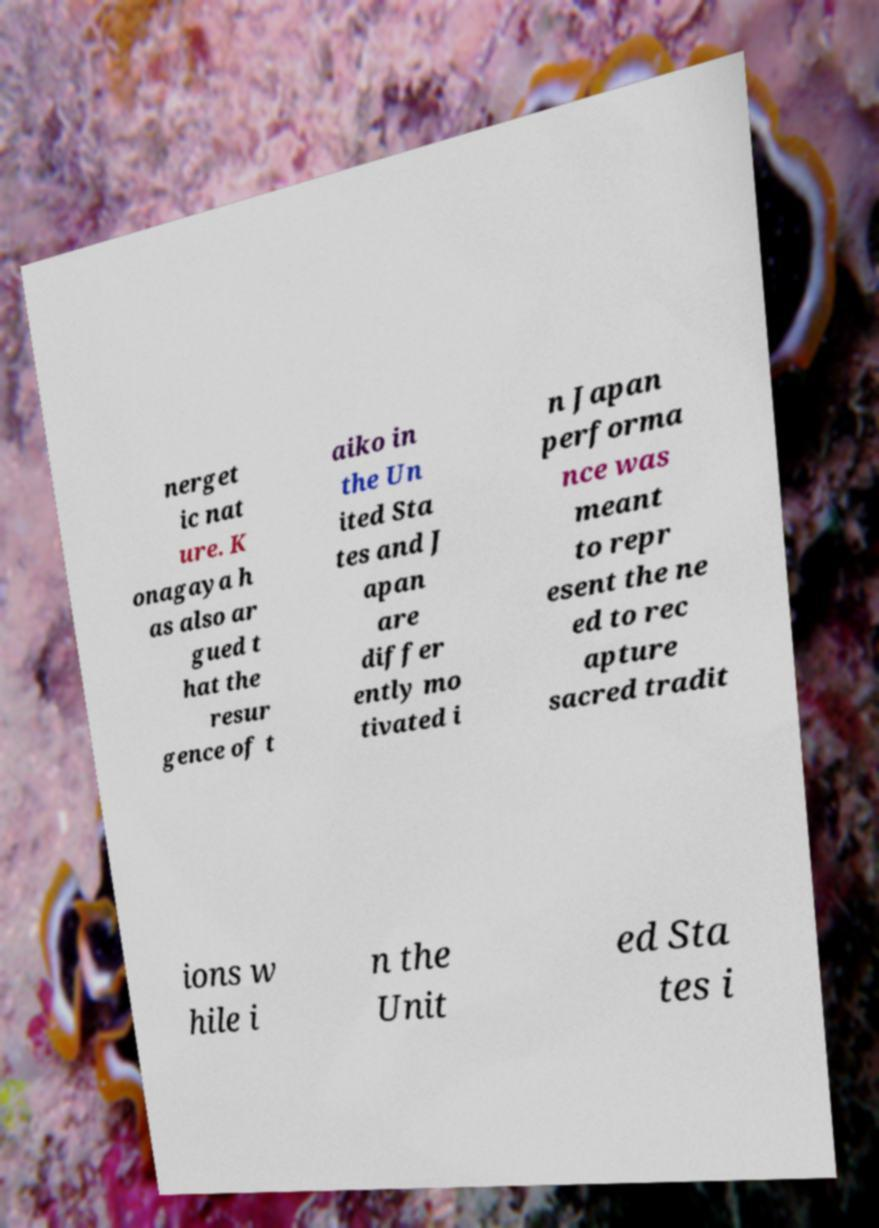For documentation purposes, I need the text within this image transcribed. Could you provide that? nerget ic nat ure. K onagaya h as also ar gued t hat the resur gence of t aiko in the Un ited Sta tes and J apan are differ ently mo tivated i n Japan performa nce was meant to repr esent the ne ed to rec apture sacred tradit ions w hile i n the Unit ed Sta tes i 